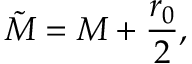<formula> <loc_0><loc_0><loc_500><loc_500>\tilde { M } = M + \frac { r _ { 0 } } { 2 } ,</formula> 